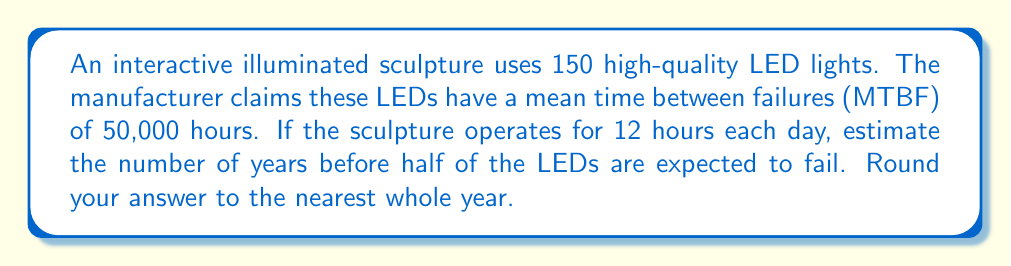Teach me how to tackle this problem. Let's approach this step-by-step:

1) First, we need to calculate the number of operating hours per year:
   $$ \text{Hours per year} = 12 \text{ hours/day} \times 365 \text{ days/year} = 4,380 \text{ hours/year} $$

2) The MTBF (Mean Time Between Failures) is 50,000 hours. This means that, on average, half of the LEDs will fail by this time.

3) To find the number of years until half the LEDs fail, we divide the MTBF by the annual operating hours:
   $$ \text{Years until half fail} = \frac{\text{MTBF}}{\text{Hours per year}} = \frac{50,000}{4,380} \approx 11.42 \text{ years} $$

4) Rounding to the nearest whole year gives us 11 years.

This calculation assumes a constant failure rate and that all LEDs are independent, which is a simplification of real-world conditions. In practice, factors like heat dissipation, power fluctuations, and environmental conditions could affect the actual lifespan of the LEDs in the sculpture.
Answer: 11 years 